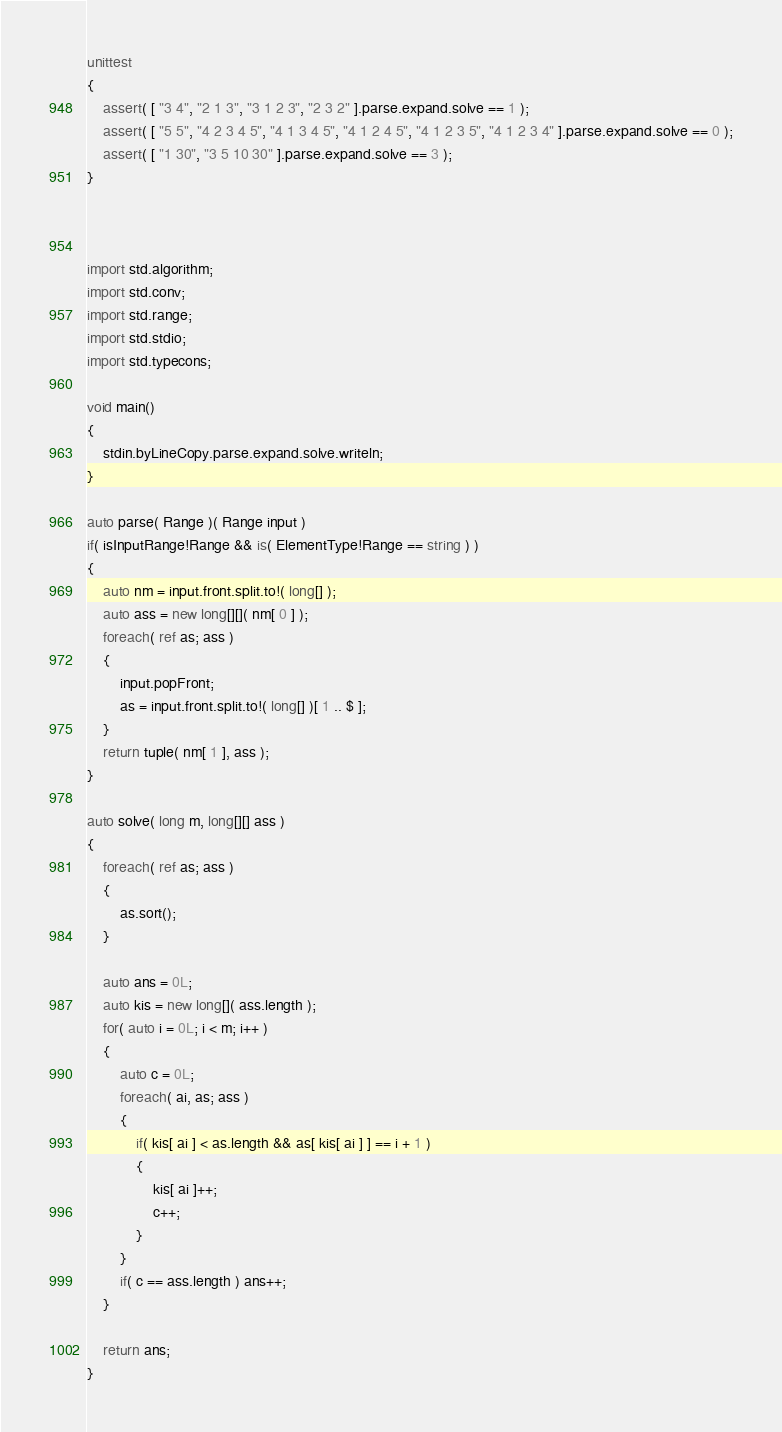<code> <loc_0><loc_0><loc_500><loc_500><_D_>unittest
{
	assert( [ "3 4", "2 1 3", "3 1 2 3", "2 3 2" ].parse.expand.solve == 1 );
	assert( [ "5 5", "4 2 3 4 5", "4 1 3 4 5", "4 1 2 4 5", "4 1 2 3 5", "4 1 2 3 4" ].parse.expand.solve == 0 );
	assert( [ "1 30", "3 5 10 30" ].parse.expand.solve == 3 );
}



import std.algorithm;
import std.conv;
import std.range;
import std.stdio;
import std.typecons;

void main()
{
	stdin.byLineCopy.parse.expand.solve.writeln;
}

auto parse( Range )( Range input )
if( isInputRange!Range && is( ElementType!Range == string ) )
{
	auto nm = input.front.split.to!( long[] );
	auto ass = new long[][]( nm[ 0 ] );
	foreach( ref as; ass )
	{
		input.popFront;
		as = input.front.split.to!( long[] )[ 1 .. $ ];
	}
	return tuple( nm[ 1 ], ass );
}

auto solve( long m, long[][] ass )
{
	foreach( ref as; ass )
	{
		as.sort();
	}
	
	auto ans = 0L;
	auto kis = new long[]( ass.length );
	for( auto i = 0L; i < m; i++ )
	{
		auto c = 0L;
		foreach( ai, as; ass )
		{
			if( kis[ ai ] < as.length && as[ kis[ ai ] ] == i + 1 )
			{
				kis[ ai ]++;
				c++;
			}
		}
		if( c == ass.length ) ans++;
	}
	
	return ans;
}
</code> 